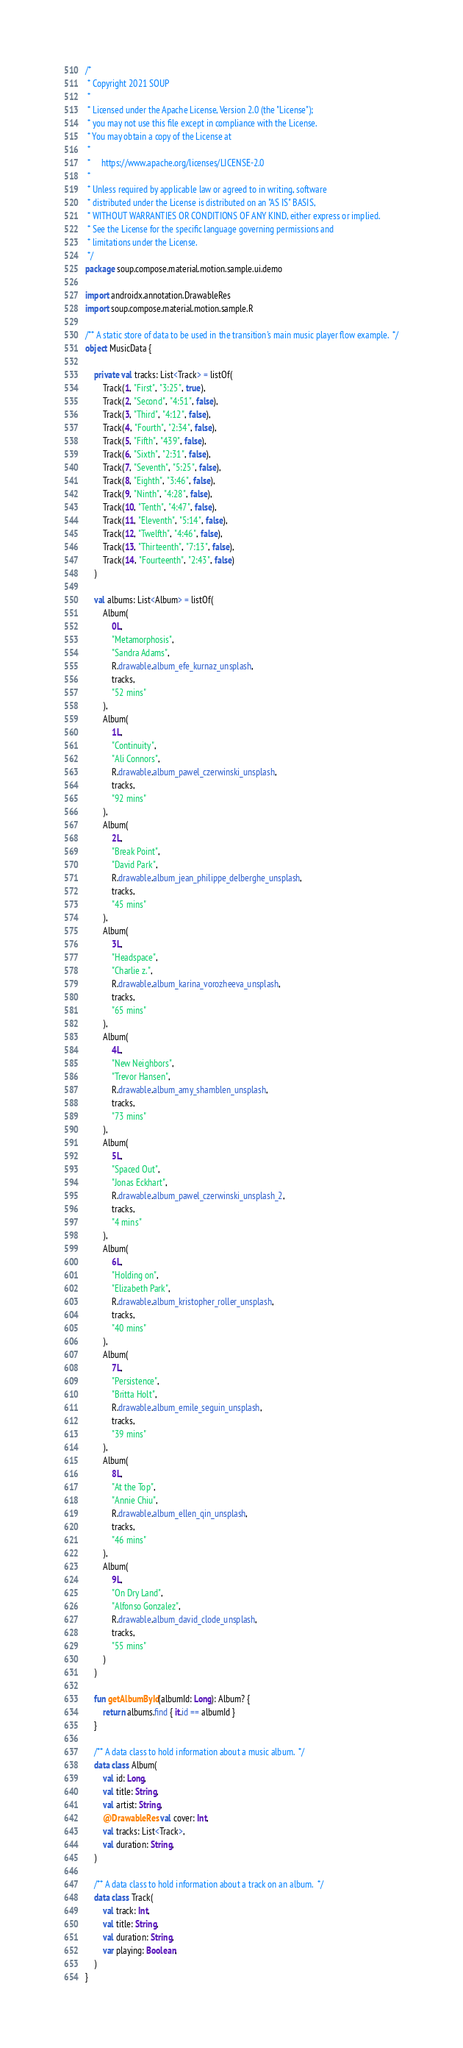<code> <loc_0><loc_0><loc_500><loc_500><_Kotlin_>/*
 * Copyright 2021 SOUP
 *
 * Licensed under the Apache License, Version 2.0 (the "License");
 * you may not use this file except in compliance with the License.
 * You may obtain a copy of the License at
 *
 *     https://www.apache.org/licenses/LICENSE-2.0
 *
 * Unless required by applicable law or agreed to in writing, software
 * distributed under the License is distributed on an "AS IS" BASIS,
 * WITHOUT WARRANTIES OR CONDITIONS OF ANY KIND, either express or implied.
 * See the License for the specific language governing permissions and
 * limitations under the License.
 */
package soup.compose.material.motion.sample.ui.demo

import androidx.annotation.DrawableRes
import soup.compose.material.motion.sample.R

/** A static store of data to be used in the transition's main music player flow example.  */
object MusicData {

    private val tracks: List<Track> = listOf(
        Track(1, "First", "3:25", true),
        Track(2, "Second", "4:51", false),
        Track(3, "Third", "4:12", false),
        Track(4, "Fourth", "2:34", false),
        Track(5, "Fifth", "439", false),
        Track(6, "Sixth", "2:31", false),
        Track(7, "Seventh", "5:25", false),
        Track(8, "Eighth", "3:46", false),
        Track(9, "Ninth", "4:28", false),
        Track(10, "Tenth", "4:47", false),
        Track(11, "Eleventh", "5:14", false),
        Track(12, "Twelfth", "4:46", false),
        Track(13, "Thirteenth", "7:13", false),
        Track(14, "Fourteenth", "2:43", false)
    )

    val albums: List<Album> = listOf(
        Album(
            0L,
            "Metamorphosis",
            "Sandra Adams",
            R.drawable.album_efe_kurnaz_unsplash,
            tracks,
            "52 mins"
        ),
        Album(
            1L,
            "Continuity",
            "Ali Connors",
            R.drawable.album_pawel_czerwinski_unsplash,
            tracks,
            "92 mins"
        ),
        Album(
            2L,
            "Break Point",
            "David Park",
            R.drawable.album_jean_philippe_delberghe_unsplash,
            tracks,
            "45 mins"
        ),
        Album(
            3L,
            "Headspace",
            "Charlie z.",
            R.drawable.album_karina_vorozheeva_unsplash,
            tracks,
            "65 mins"
        ),
        Album(
            4L,
            "New Neighbors",
            "Trevor Hansen",
            R.drawable.album_amy_shamblen_unsplash,
            tracks,
            "73 mins"
        ),
        Album(
            5L,
            "Spaced Out",
            "Jonas Eckhart",
            R.drawable.album_pawel_czerwinski_unsplash_2,
            tracks,
            "4 mins"
        ),
        Album(
            6L,
            "Holding on",
            "Elizabeth Park",
            R.drawable.album_kristopher_roller_unsplash,
            tracks,
            "40 mins"
        ),
        Album(
            7L,
            "Persistence",
            "Britta Holt",
            R.drawable.album_emile_seguin_unsplash,
            tracks,
            "39 mins"
        ),
        Album(
            8L,
            "At the Top",
            "Annie Chiu",
            R.drawable.album_ellen_qin_unsplash,
            tracks,
            "46 mins"
        ),
        Album(
            9L,
            "On Dry Land",
            "Alfonso Gonzalez",
            R.drawable.album_david_clode_unsplash,
            tracks,
            "55 mins"
        )
    )

    fun getAlbumById(albumId: Long): Album? {
        return albums.find { it.id == albumId }
    }

    /** A data class to hold information about a music album.  */
    data class Album(
        val id: Long,
        val title: String,
        val artist: String,
        @DrawableRes val cover: Int,
        val tracks: List<Track>,
        val duration: String,
    )

    /** A data class to hold information about a track on an album.  */
    data class Track(
        val track: Int,
        val title: String,
        val duration: String,
        var playing: Boolean,
    )
}
</code> 